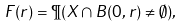Convert formula to latex. <formula><loc_0><loc_0><loc_500><loc_500>F ( r ) = \P ( X \cap B ( 0 , r ) \neq \emptyset ) ,</formula> 